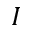Convert formula to latex. <formula><loc_0><loc_0><loc_500><loc_500>I</formula> 